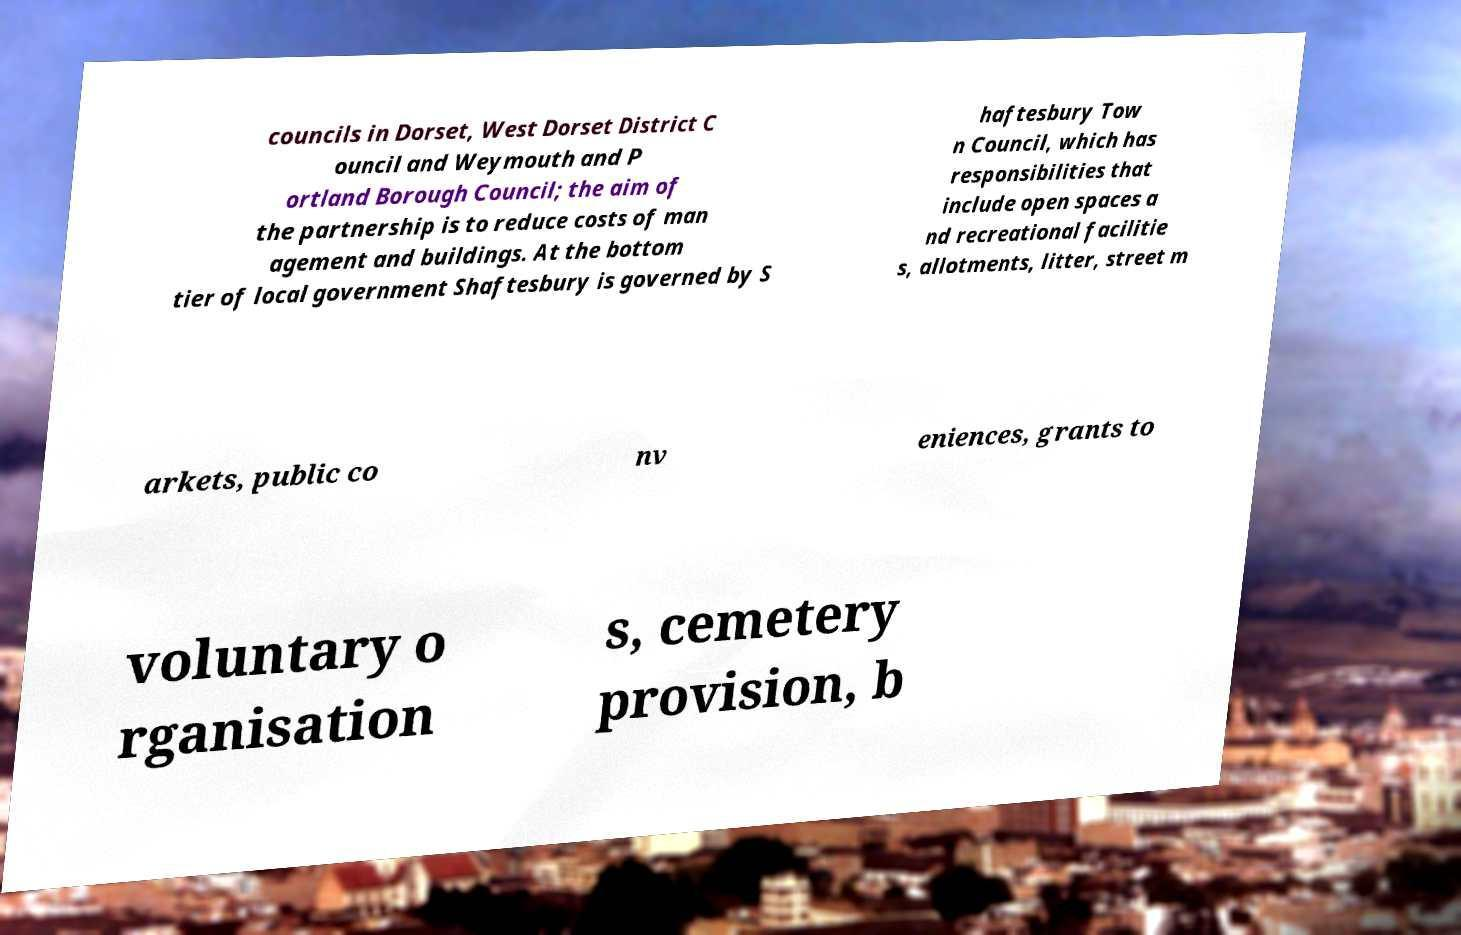Could you extract and type out the text from this image? councils in Dorset, West Dorset District C ouncil and Weymouth and P ortland Borough Council; the aim of the partnership is to reduce costs of man agement and buildings. At the bottom tier of local government Shaftesbury is governed by S haftesbury Tow n Council, which has responsibilities that include open spaces a nd recreational facilitie s, allotments, litter, street m arkets, public co nv eniences, grants to voluntary o rganisation s, cemetery provision, b 